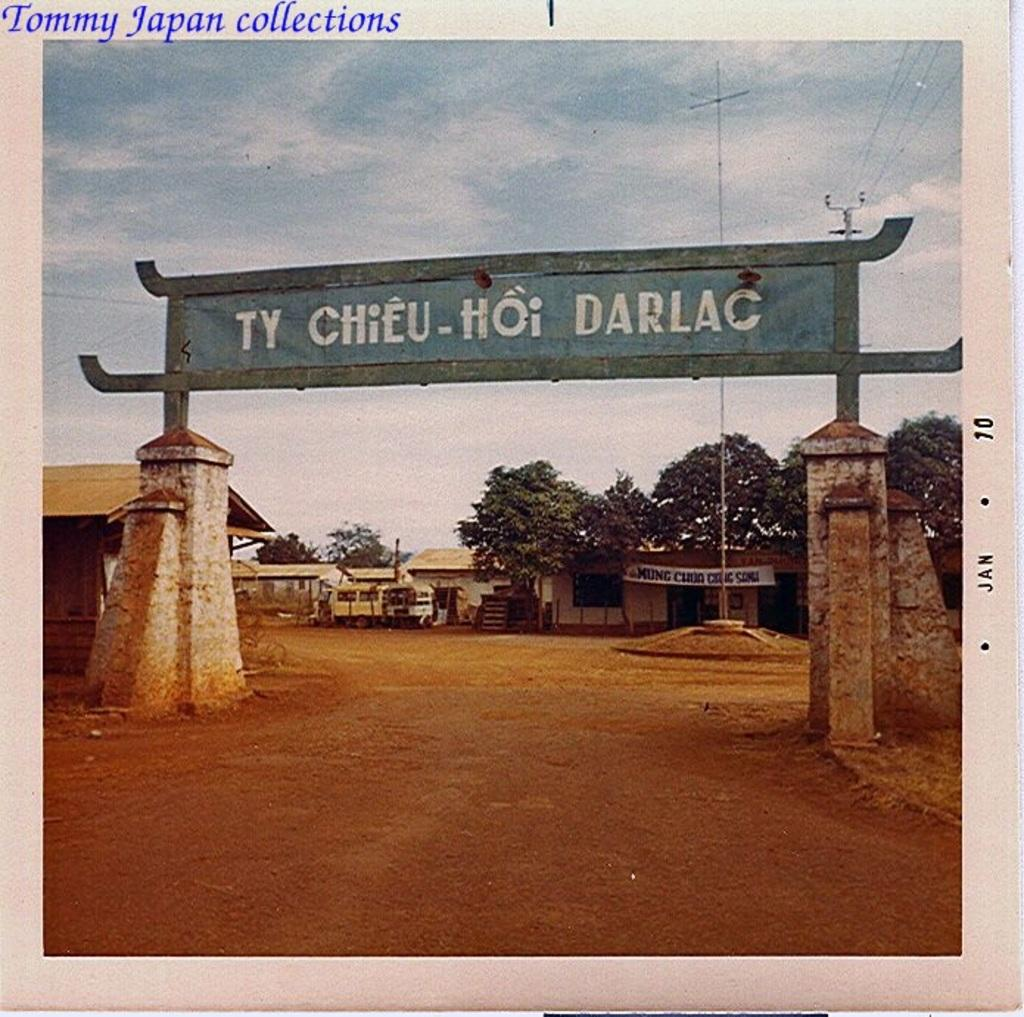Provide a one-sentence caption for the provided image. An archway sign over a road entrance that reads Ty Chieu-Hoi Darlac. 